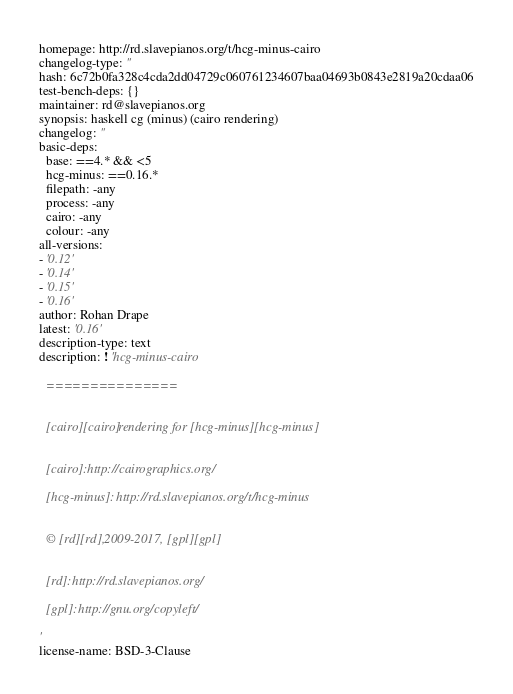<code> <loc_0><loc_0><loc_500><loc_500><_YAML_>homepage: http://rd.slavepianos.org/t/hcg-minus-cairo
changelog-type: ''
hash: 6c72b0fa328c4cda2dd04729c060761234607baa04693b0843e2819a20cdaa06
test-bench-deps: {}
maintainer: rd@slavepianos.org
synopsis: haskell cg (minus) (cairo rendering)
changelog: ''
basic-deps:
  base: ==4.* && <5
  hcg-minus: ==0.16.*
  filepath: -any
  process: -any
  cairo: -any
  colour: -any
all-versions:
- '0.12'
- '0.14'
- '0.15'
- '0.16'
author: Rohan Drape
latest: '0.16'
description-type: text
description: ! 'hcg-minus-cairo

  ===============


  [cairo][cairo] rendering for [hcg-minus][hcg-minus]


  [cairo]: http://cairographics.org/

  [hcg-minus]: http://rd.slavepianos.org/t/hcg-minus


  © [rd][rd], 2009-2017, [gpl][gpl]


  [rd]: http://rd.slavepianos.org/

  [gpl]: http://gnu.org/copyleft/

'
license-name: BSD-3-Clause
</code> 